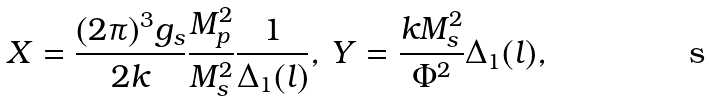Convert formula to latex. <formula><loc_0><loc_0><loc_500><loc_500>X = \frac { ( 2 \pi ) ^ { 3 } g _ { s } } { 2 k } \frac { M _ { p } ^ { 2 } } { M _ { s } ^ { 2 } } \frac { 1 } { \Delta _ { 1 } ( l ) } , \, Y = \frac { k M _ { s } ^ { 2 } } { \Phi ^ { 2 } } \Delta _ { 1 } ( l ) ,</formula> 